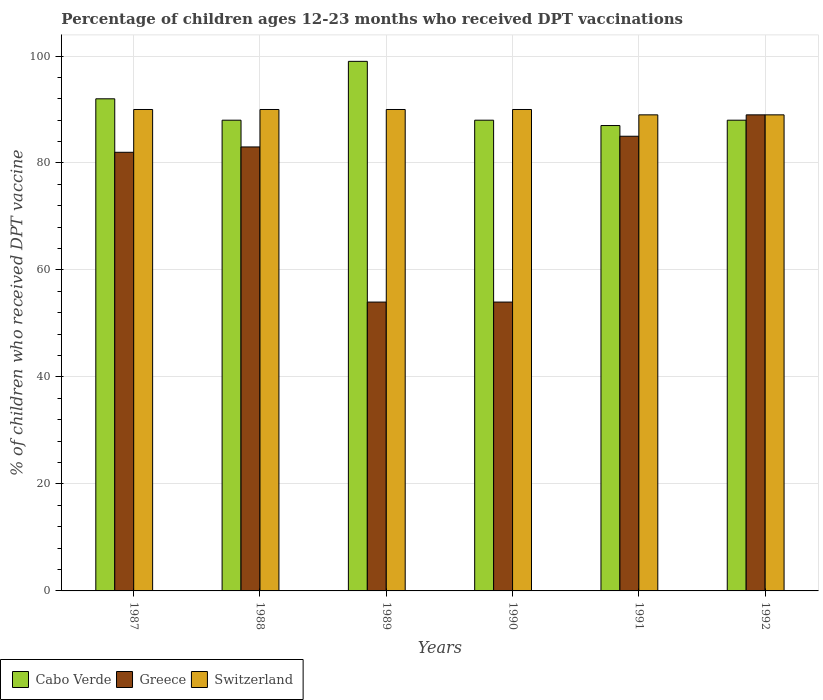How many different coloured bars are there?
Offer a terse response. 3. How many groups of bars are there?
Your answer should be very brief. 6. Are the number of bars per tick equal to the number of legend labels?
Offer a terse response. Yes. Are the number of bars on each tick of the X-axis equal?
Your answer should be compact. Yes. How many bars are there on the 6th tick from the left?
Provide a short and direct response. 3. What is the percentage of children who received DPT vaccination in Greece in 1991?
Offer a very short reply. 85. Across all years, what is the maximum percentage of children who received DPT vaccination in Greece?
Your answer should be very brief. 89. In which year was the percentage of children who received DPT vaccination in Switzerland minimum?
Your answer should be compact. 1991. What is the total percentage of children who received DPT vaccination in Switzerland in the graph?
Your response must be concise. 538. What is the average percentage of children who received DPT vaccination in Switzerland per year?
Your response must be concise. 89.67. In the year 1990, what is the difference between the percentage of children who received DPT vaccination in Greece and percentage of children who received DPT vaccination in Switzerland?
Make the answer very short. -36. What is the ratio of the percentage of children who received DPT vaccination in Cabo Verde in 1987 to that in 1990?
Give a very brief answer. 1.05. What is the difference between the highest and the second highest percentage of children who received DPT vaccination in Greece?
Your response must be concise. 4. Is the sum of the percentage of children who received DPT vaccination in Greece in 1987 and 1989 greater than the maximum percentage of children who received DPT vaccination in Cabo Verde across all years?
Your answer should be compact. Yes. What does the 1st bar from the left in 1992 represents?
Your answer should be very brief. Cabo Verde. What does the 1st bar from the right in 1992 represents?
Provide a short and direct response. Switzerland. How many years are there in the graph?
Provide a short and direct response. 6. Does the graph contain any zero values?
Keep it short and to the point. No. Where does the legend appear in the graph?
Provide a succinct answer. Bottom left. How are the legend labels stacked?
Give a very brief answer. Horizontal. What is the title of the graph?
Your response must be concise. Percentage of children ages 12-23 months who received DPT vaccinations. What is the label or title of the X-axis?
Give a very brief answer. Years. What is the label or title of the Y-axis?
Offer a very short reply. % of children who received DPT vaccine. What is the % of children who received DPT vaccine of Cabo Verde in 1987?
Provide a succinct answer. 92. What is the % of children who received DPT vaccine in Greece in 1987?
Your response must be concise. 82. What is the % of children who received DPT vaccine in Cabo Verde in 1988?
Your answer should be compact. 88. What is the % of children who received DPT vaccine of Greece in 1988?
Make the answer very short. 83. What is the % of children who received DPT vaccine of Cabo Verde in 1989?
Your response must be concise. 99. What is the % of children who received DPT vaccine in Greece in 1989?
Offer a very short reply. 54. What is the % of children who received DPT vaccine of Switzerland in 1989?
Offer a very short reply. 90. What is the % of children who received DPT vaccine in Cabo Verde in 1990?
Your answer should be compact. 88. What is the % of children who received DPT vaccine of Greece in 1991?
Make the answer very short. 85. What is the % of children who received DPT vaccine of Switzerland in 1991?
Provide a succinct answer. 89. What is the % of children who received DPT vaccine in Greece in 1992?
Offer a terse response. 89. What is the % of children who received DPT vaccine of Switzerland in 1992?
Offer a very short reply. 89. Across all years, what is the maximum % of children who received DPT vaccine in Greece?
Ensure brevity in your answer.  89. Across all years, what is the minimum % of children who received DPT vaccine in Cabo Verde?
Your answer should be compact. 87. Across all years, what is the minimum % of children who received DPT vaccine in Greece?
Provide a succinct answer. 54. Across all years, what is the minimum % of children who received DPT vaccine in Switzerland?
Your answer should be compact. 89. What is the total % of children who received DPT vaccine of Cabo Verde in the graph?
Provide a short and direct response. 542. What is the total % of children who received DPT vaccine of Greece in the graph?
Give a very brief answer. 447. What is the total % of children who received DPT vaccine in Switzerland in the graph?
Your answer should be compact. 538. What is the difference between the % of children who received DPT vaccine in Greece in 1987 and that in 1988?
Make the answer very short. -1. What is the difference between the % of children who received DPT vaccine of Cabo Verde in 1987 and that in 1989?
Offer a very short reply. -7. What is the difference between the % of children who received DPT vaccine in Greece in 1987 and that in 1989?
Offer a terse response. 28. What is the difference between the % of children who received DPT vaccine of Switzerland in 1987 and that in 1989?
Give a very brief answer. 0. What is the difference between the % of children who received DPT vaccine in Cabo Verde in 1987 and that in 1990?
Give a very brief answer. 4. What is the difference between the % of children who received DPT vaccine in Greece in 1987 and that in 1990?
Your answer should be very brief. 28. What is the difference between the % of children who received DPT vaccine in Switzerland in 1987 and that in 1990?
Offer a terse response. 0. What is the difference between the % of children who received DPT vaccine in Greece in 1987 and that in 1992?
Provide a succinct answer. -7. What is the difference between the % of children who received DPT vaccine in Switzerland in 1987 and that in 1992?
Your answer should be compact. 1. What is the difference between the % of children who received DPT vaccine of Cabo Verde in 1988 and that in 1989?
Give a very brief answer. -11. What is the difference between the % of children who received DPT vaccine of Switzerland in 1988 and that in 1989?
Your answer should be very brief. 0. What is the difference between the % of children who received DPT vaccine in Greece in 1988 and that in 1990?
Your answer should be compact. 29. What is the difference between the % of children who received DPT vaccine of Switzerland in 1988 and that in 1990?
Offer a terse response. 0. What is the difference between the % of children who received DPT vaccine of Greece in 1988 and that in 1991?
Keep it short and to the point. -2. What is the difference between the % of children who received DPT vaccine of Cabo Verde in 1988 and that in 1992?
Offer a terse response. 0. What is the difference between the % of children who received DPT vaccine of Greece in 1988 and that in 1992?
Offer a very short reply. -6. What is the difference between the % of children who received DPT vaccine of Cabo Verde in 1989 and that in 1991?
Offer a very short reply. 12. What is the difference between the % of children who received DPT vaccine of Greece in 1989 and that in 1991?
Provide a short and direct response. -31. What is the difference between the % of children who received DPT vaccine in Switzerland in 1989 and that in 1991?
Your answer should be very brief. 1. What is the difference between the % of children who received DPT vaccine of Cabo Verde in 1989 and that in 1992?
Keep it short and to the point. 11. What is the difference between the % of children who received DPT vaccine of Greece in 1989 and that in 1992?
Provide a succinct answer. -35. What is the difference between the % of children who received DPT vaccine of Cabo Verde in 1990 and that in 1991?
Your answer should be compact. 1. What is the difference between the % of children who received DPT vaccine in Greece in 1990 and that in 1991?
Your answer should be very brief. -31. What is the difference between the % of children who received DPT vaccine of Switzerland in 1990 and that in 1991?
Give a very brief answer. 1. What is the difference between the % of children who received DPT vaccine in Greece in 1990 and that in 1992?
Provide a short and direct response. -35. What is the difference between the % of children who received DPT vaccine in Switzerland in 1990 and that in 1992?
Give a very brief answer. 1. What is the difference between the % of children who received DPT vaccine in Cabo Verde in 1991 and that in 1992?
Ensure brevity in your answer.  -1. What is the difference between the % of children who received DPT vaccine of Greece in 1991 and that in 1992?
Ensure brevity in your answer.  -4. What is the difference between the % of children who received DPT vaccine in Cabo Verde in 1987 and the % of children who received DPT vaccine in Greece in 1988?
Your response must be concise. 9. What is the difference between the % of children who received DPT vaccine of Cabo Verde in 1987 and the % of children who received DPT vaccine of Switzerland in 1988?
Your answer should be compact. 2. What is the difference between the % of children who received DPT vaccine of Greece in 1987 and the % of children who received DPT vaccine of Switzerland in 1989?
Your answer should be very brief. -8. What is the difference between the % of children who received DPT vaccine in Cabo Verde in 1987 and the % of children who received DPT vaccine in Greece in 1990?
Your answer should be compact. 38. What is the difference between the % of children who received DPT vaccine of Cabo Verde in 1987 and the % of children who received DPT vaccine of Switzerland in 1991?
Ensure brevity in your answer.  3. What is the difference between the % of children who received DPT vaccine of Greece in 1987 and the % of children who received DPT vaccine of Switzerland in 1991?
Your answer should be compact. -7. What is the difference between the % of children who received DPT vaccine in Cabo Verde in 1987 and the % of children who received DPT vaccine in Switzerland in 1992?
Give a very brief answer. 3. What is the difference between the % of children who received DPT vaccine in Greece in 1987 and the % of children who received DPT vaccine in Switzerland in 1992?
Give a very brief answer. -7. What is the difference between the % of children who received DPT vaccine in Cabo Verde in 1988 and the % of children who received DPT vaccine in Greece in 1989?
Your answer should be very brief. 34. What is the difference between the % of children who received DPT vaccine of Cabo Verde in 1988 and the % of children who received DPT vaccine of Switzerland in 1989?
Make the answer very short. -2. What is the difference between the % of children who received DPT vaccine in Cabo Verde in 1988 and the % of children who received DPT vaccine in Greece in 1990?
Offer a very short reply. 34. What is the difference between the % of children who received DPT vaccine in Cabo Verde in 1988 and the % of children who received DPT vaccine in Switzerland in 1990?
Your answer should be very brief. -2. What is the difference between the % of children who received DPT vaccine of Cabo Verde in 1988 and the % of children who received DPT vaccine of Greece in 1991?
Offer a terse response. 3. What is the difference between the % of children who received DPT vaccine in Cabo Verde in 1988 and the % of children who received DPT vaccine in Switzerland in 1991?
Ensure brevity in your answer.  -1. What is the difference between the % of children who received DPT vaccine of Cabo Verde in 1988 and the % of children who received DPT vaccine of Switzerland in 1992?
Give a very brief answer. -1. What is the difference between the % of children who received DPT vaccine in Cabo Verde in 1989 and the % of children who received DPT vaccine in Switzerland in 1990?
Keep it short and to the point. 9. What is the difference between the % of children who received DPT vaccine of Greece in 1989 and the % of children who received DPT vaccine of Switzerland in 1990?
Give a very brief answer. -36. What is the difference between the % of children who received DPT vaccine of Cabo Verde in 1989 and the % of children who received DPT vaccine of Switzerland in 1991?
Your answer should be compact. 10. What is the difference between the % of children who received DPT vaccine in Greece in 1989 and the % of children who received DPT vaccine in Switzerland in 1991?
Provide a succinct answer. -35. What is the difference between the % of children who received DPT vaccine of Cabo Verde in 1989 and the % of children who received DPT vaccine of Switzerland in 1992?
Make the answer very short. 10. What is the difference between the % of children who received DPT vaccine of Greece in 1989 and the % of children who received DPT vaccine of Switzerland in 1992?
Keep it short and to the point. -35. What is the difference between the % of children who received DPT vaccine in Cabo Verde in 1990 and the % of children who received DPT vaccine in Greece in 1991?
Give a very brief answer. 3. What is the difference between the % of children who received DPT vaccine of Cabo Verde in 1990 and the % of children who received DPT vaccine of Switzerland in 1991?
Offer a terse response. -1. What is the difference between the % of children who received DPT vaccine in Greece in 1990 and the % of children who received DPT vaccine in Switzerland in 1991?
Provide a short and direct response. -35. What is the difference between the % of children who received DPT vaccine in Cabo Verde in 1990 and the % of children who received DPT vaccine in Greece in 1992?
Your answer should be compact. -1. What is the difference between the % of children who received DPT vaccine of Greece in 1990 and the % of children who received DPT vaccine of Switzerland in 1992?
Provide a short and direct response. -35. What is the difference between the % of children who received DPT vaccine of Cabo Verde in 1991 and the % of children who received DPT vaccine of Greece in 1992?
Provide a succinct answer. -2. What is the difference between the % of children who received DPT vaccine of Greece in 1991 and the % of children who received DPT vaccine of Switzerland in 1992?
Make the answer very short. -4. What is the average % of children who received DPT vaccine in Cabo Verde per year?
Ensure brevity in your answer.  90.33. What is the average % of children who received DPT vaccine of Greece per year?
Provide a succinct answer. 74.5. What is the average % of children who received DPT vaccine of Switzerland per year?
Offer a terse response. 89.67. In the year 1987, what is the difference between the % of children who received DPT vaccine in Cabo Verde and % of children who received DPT vaccine in Switzerland?
Give a very brief answer. 2. In the year 1988, what is the difference between the % of children who received DPT vaccine in Cabo Verde and % of children who received DPT vaccine in Greece?
Give a very brief answer. 5. In the year 1988, what is the difference between the % of children who received DPT vaccine of Cabo Verde and % of children who received DPT vaccine of Switzerland?
Give a very brief answer. -2. In the year 1989, what is the difference between the % of children who received DPT vaccine in Greece and % of children who received DPT vaccine in Switzerland?
Offer a terse response. -36. In the year 1990, what is the difference between the % of children who received DPT vaccine of Greece and % of children who received DPT vaccine of Switzerland?
Your answer should be very brief. -36. In the year 1991, what is the difference between the % of children who received DPT vaccine of Cabo Verde and % of children who received DPT vaccine of Greece?
Provide a short and direct response. 2. In the year 1991, what is the difference between the % of children who received DPT vaccine in Greece and % of children who received DPT vaccine in Switzerland?
Provide a short and direct response. -4. In the year 1992, what is the difference between the % of children who received DPT vaccine in Cabo Verde and % of children who received DPT vaccine in Greece?
Provide a succinct answer. -1. In the year 1992, what is the difference between the % of children who received DPT vaccine of Greece and % of children who received DPT vaccine of Switzerland?
Provide a short and direct response. 0. What is the ratio of the % of children who received DPT vaccine of Cabo Verde in 1987 to that in 1988?
Offer a terse response. 1.05. What is the ratio of the % of children who received DPT vaccine in Switzerland in 1987 to that in 1988?
Give a very brief answer. 1. What is the ratio of the % of children who received DPT vaccine in Cabo Verde in 1987 to that in 1989?
Offer a terse response. 0.93. What is the ratio of the % of children who received DPT vaccine of Greece in 1987 to that in 1989?
Make the answer very short. 1.52. What is the ratio of the % of children who received DPT vaccine of Cabo Verde in 1987 to that in 1990?
Your response must be concise. 1.05. What is the ratio of the % of children who received DPT vaccine in Greece in 1987 to that in 1990?
Provide a short and direct response. 1.52. What is the ratio of the % of children who received DPT vaccine of Switzerland in 1987 to that in 1990?
Provide a short and direct response. 1. What is the ratio of the % of children who received DPT vaccine of Cabo Verde in 1987 to that in 1991?
Provide a short and direct response. 1.06. What is the ratio of the % of children who received DPT vaccine of Greece in 1987 to that in 1991?
Your answer should be compact. 0.96. What is the ratio of the % of children who received DPT vaccine in Switzerland in 1987 to that in 1991?
Keep it short and to the point. 1.01. What is the ratio of the % of children who received DPT vaccine in Cabo Verde in 1987 to that in 1992?
Ensure brevity in your answer.  1.05. What is the ratio of the % of children who received DPT vaccine in Greece in 1987 to that in 1992?
Keep it short and to the point. 0.92. What is the ratio of the % of children who received DPT vaccine in Switzerland in 1987 to that in 1992?
Keep it short and to the point. 1.01. What is the ratio of the % of children who received DPT vaccine in Greece in 1988 to that in 1989?
Keep it short and to the point. 1.54. What is the ratio of the % of children who received DPT vaccine in Switzerland in 1988 to that in 1989?
Your answer should be compact. 1. What is the ratio of the % of children who received DPT vaccine in Cabo Verde in 1988 to that in 1990?
Make the answer very short. 1. What is the ratio of the % of children who received DPT vaccine in Greece in 1988 to that in 1990?
Keep it short and to the point. 1.54. What is the ratio of the % of children who received DPT vaccine of Switzerland in 1988 to that in 1990?
Ensure brevity in your answer.  1. What is the ratio of the % of children who received DPT vaccine of Cabo Verde in 1988 to that in 1991?
Ensure brevity in your answer.  1.01. What is the ratio of the % of children who received DPT vaccine in Greece in 1988 to that in 1991?
Your answer should be very brief. 0.98. What is the ratio of the % of children who received DPT vaccine of Switzerland in 1988 to that in 1991?
Provide a succinct answer. 1.01. What is the ratio of the % of children who received DPT vaccine of Greece in 1988 to that in 1992?
Your answer should be very brief. 0.93. What is the ratio of the % of children who received DPT vaccine of Switzerland in 1988 to that in 1992?
Provide a succinct answer. 1.01. What is the ratio of the % of children who received DPT vaccine in Greece in 1989 to that in 1990?
Give a very brief answer. 1. What is the ratio of the % of children who received DPT vaccine of Cabo Verde in 1989 to that in 1991?
Provide a succinct answer. 1.14. What is the ratio of the % of children who received DPT vaccine of Greece in 1989 to that in 1991?
Ensure brevity in your answer.  0.64. What is the ratio of the % of children who received DPT vaccine in Switzerland in 1989 to that in 1991?
Offer a terse response. 1.01. What is the ratio of the % of children who received DPT vaccine in Cabo Verde in 1989 to that in 1992?
Give a very brief answer. 1.12. What is the ratio of the % of children who received DPT vaccine of Greece in 1989 to that in 1992?
Your response must be concise. 0.61. What is the ratio of the % of children who received DPT vaccine of Switzerland in 1989 to that in 1992?
Offer a very short reply. 1.01. What is the ratio of the % of children who received DPT vaccine of Cabo Verde in 1990 to that in 1991?
Ensure brevity in your answer.  1.01. What is the ratio of the % of children who received DPT vaccine of Greece in 1990 to that in 1991?
Provide a short and direct response. 0.64. What is the ratio of the % of children who received DPT vaccine of Switzerland in 1990 to that in 1991?
Provide a short and direct response. 1.01. What is the ratio of the % of children who received DPT vaccine in Cabo Verde in 1990 to that in 1992?
Give a very brief answer. 1. What is the ratio of the % of children who received DPT vaccine of Greece in 1990 to that in 1992?
Keep it short and to the point. 0.61. What is the ratio of the % of children who received DPT vaccine in Switzerland in 1990 to that in 1992?
Offer a terse response. 1.01. What is the ratio of the % of children who received DPT vaccine in Greece in 1991 to that in 1992?
Make the answer very short. 0.96. What is the difference between the highest and the second highest % of children who received DPT vaccine in Greece?
Keep it short and to the point. 4. What is the difference between the highest and the lowest % of children who received DPT vaccine in Cabo Verde?
Your answer should be compact. 12. What is the difference between the highest and the lowest % of children who received DPT vaccine of Switzerland?
Make the answer very short. 1. 